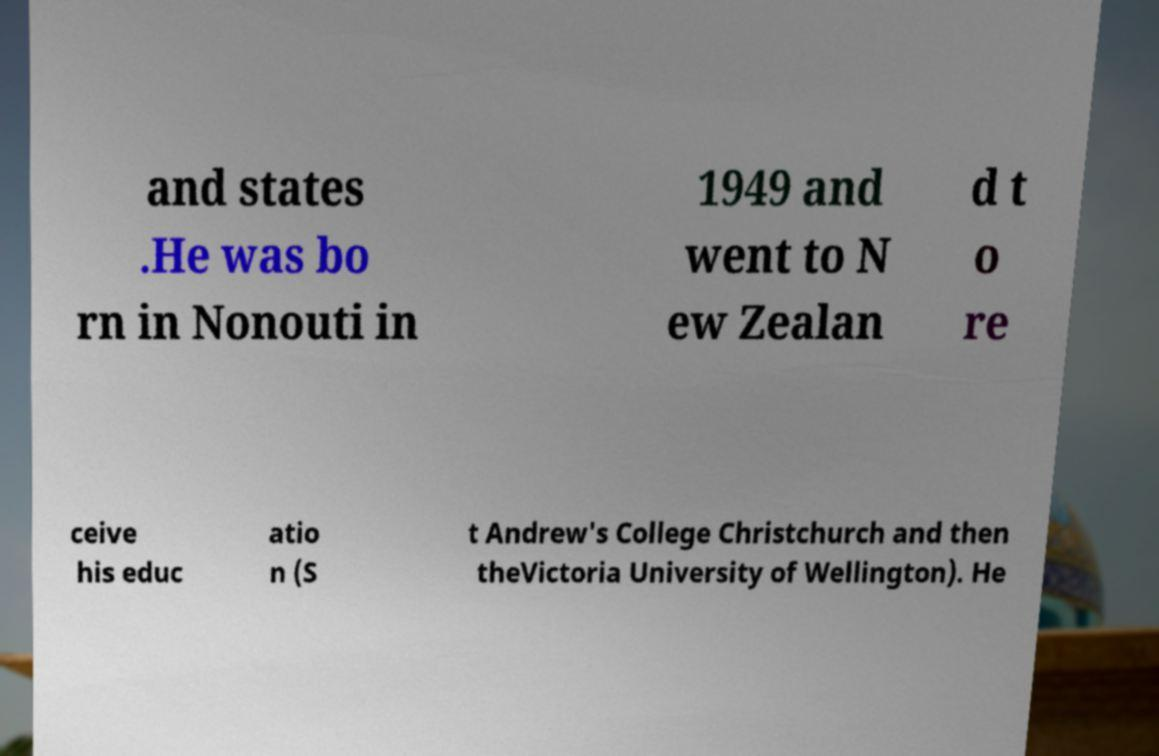Could you extract and type out the text from this image? and states .He was bo rn in Nonouti in 1949 and went to N ew Zealan d t o re ceive his educ atio n (S t Andrew's College Christchurch and then theVictoria University of Wellington). He 